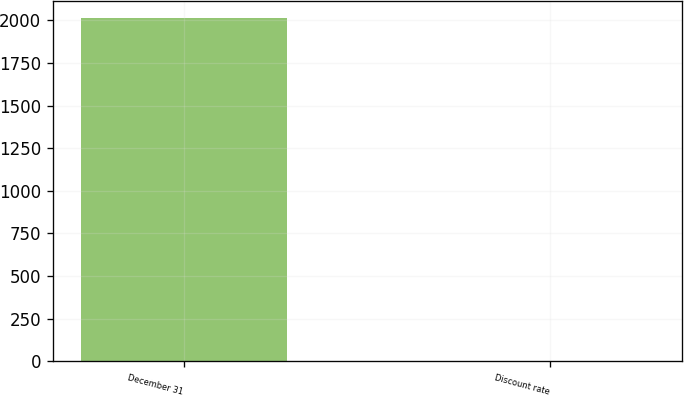Convert chart. <chart><loc_0><loc_0><loc_500><loc_500><bar_chart><fcel>December 31<fcel>Discount rate<nl><fcel>2015<fcel>4.25<nl></chart> 